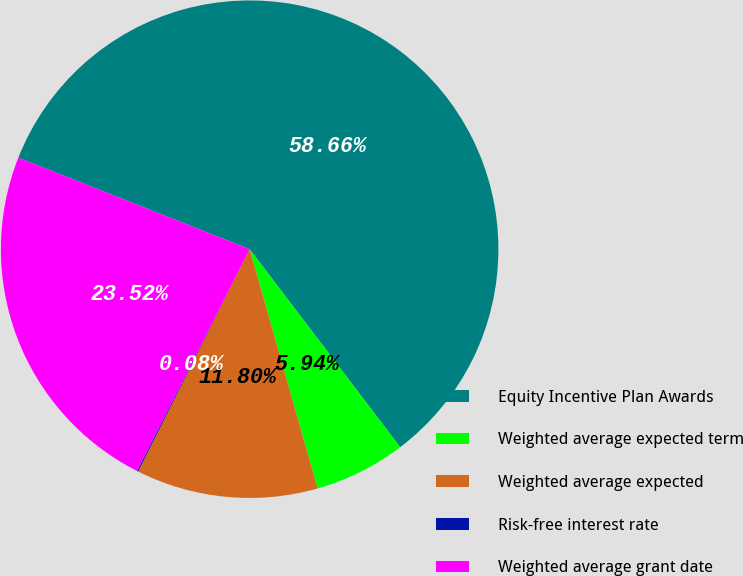Convert chart. <chart><loc_0><loc_0><loc_500><loc_500><pie_chart><fcel>Equity Incentive Plan Awards<fcel>Weighted average expected term<fcel>Weighted average expected<fcel>Risk-free interest rate<fcel>Weighted average grant date<nl><fcel>58.66%<fcel>5.94%<fcel>11.8%<fcel>0.08%<fcel>23.52%<nl></chart> 